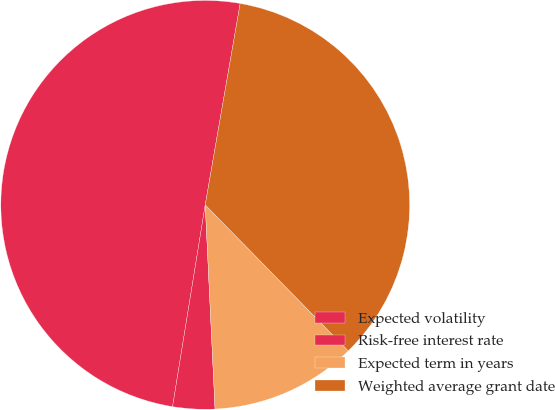Convert chart. <chart><loc_0><loc_0><loc_500><loc_500><pie_chart><fcel>Expected volatility<fcel>Risk-free interest rate<fcel>Expected term in years<fcel>Weighted average grant date<nl><fcel>50.18%<fcel>3.32%<fcel>11.57%<fcel>34.93%<nl></chart> 